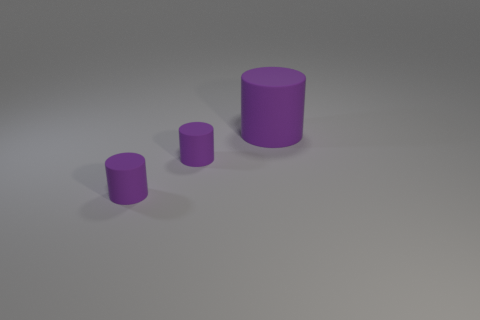Are there any objects that have the same color as the large cylinder?
Provide a short and direct response. Yes. How many objects are either things that are left of the large purple matte object or large purple cylinders?
Keep it short and to the point. 3. Are there any purple objects made of the same material as the large cylinder?
Your answer should be compact. Yes. What number of objects are either purple cylinders that are on the left side of the big matte cylinder or purple matte things left of the large purple matte cylinder?
Provide a short and direct response. 2. How many other objects are the same shape as the large purple object?
Your response must be concise. 2. What number of things are small cylinders or big cylinders?
Your answer should be very brief. 3. Is the number of small metal blocks less than the number of tiny purple matte objects?
Keep it short and to the point. Yes. What number of cylinders are to the right of the big matte thing?
Keep it short and to the point. 0. Are there more small gray matte things than purple rubber cylinders?
Your answer should be very brief. No. Are there any purple things?
Offer a very short reply. Yes. 